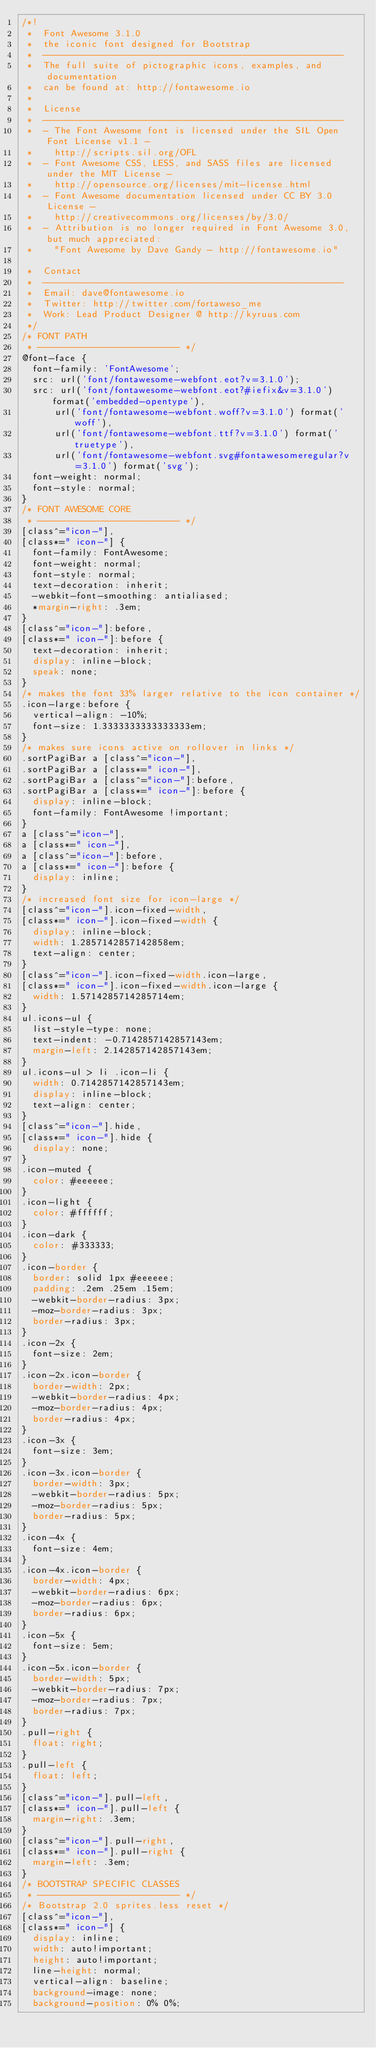<code> <loc_0><loc_0><loc_500><loc_500><_CSS_>/*!
 *  Font Awesome 3.1.0
 *  the iconic font designed for Bootstrap
 *  -------------------------------------------------------
 *  The full suite of pictographic icons, examples, and documentation
 *  can be found at: http://fontawesome.io
 *
 *  License
 *  -------------------------------------------------------
 *  - The Font Awesome font is licensed under the SIL Open Font License v1.1 -
 *    http://scripts.sil.org/OFL
 *  - Font Awesome CSS, LESS, and SASS files are licensed under the MIT License -
 *    http://opensource.org/licenses/mit-license.html
 *  - Font Awesome documentation licensed under CC BY 3.0 License -
 *    http://creativecommons.org/licenses/by/3.0/
 *  - Attribution is no longer required in Font Awesome 3.0, but much appreciated:
 *    "Font Awesome by Dave Gandy - http://fontawesome.io"

 *  Contact
 *  -------------------------------------------------------
 *  Email: dave@fontawesome.io
 *  Twitter: http://twitter.com/fortaweso_me
 *  Work: Lead Product Designer @ http://kyruus.com
 */
/* FONT PATH
 * -------------------------- */
@font-face {
  font-family: 'FontAwesome';
  src: url('font/fontawesome-webfont.eot?v=3.1.0');
  src: url('font/fontawesome-webfont.eot?#iefix&v=3.1.0') format('embedded-opentype'),
      url('font/fontawesome-webfont.woff?v=3.1.0') format('woff'),
      url('font/fontawesome-webfont.ttf?v=3.1.0') format('truetype'),
      url('font/fontawesome-webfont.svg#fontawesomeregular?v=3.1.0') format('svg');
  font-weight: normal;
  font-style: normal;
}
/* FONT AWESOME CORE
 * -------------------------- */
[class^="icon-"],
[class*=" icon-"] {
  font-family: FontAwesome;
  font-weight: normal;
  font-style: normal;
  text-decoration: inherit;
  -webkit-font-smoothing: antialiased;
  *margin-right: .3em;
}
[class^="icon-"]:before,
[class*=" icon-"]:before {
  text-decoration: inherit;
  display: inline-block;
  speak: none;
}
/* makes the font 33% larger relative to the icon container */
.icon-large:before {
  vertical-align: -10%;
  font-size: 1.3333333333333333em;
}
/* makes sure icons active on rollover in links */
.sortPagiBar a [class^="icon-"],
.sortPagiBar a [class*=" icon-"],
.sortPagiBar a [class^="icon-"]:before,
.sortPagiBar a [class*=" icon-"]:before {
  display: inline-block;
  font-family: FontAwesome !important;
}
a [class^="icon-"],
a [class*=" icon-"],
a [class^="icon-"]:before,
a [class*=" icon-"]:before {
  display: inline;
}
/* increased font size for icon-large */
[class^="icon-"].icon-fixed-width,
[class*=" icon-"].icon-fixed-width {
  display: inline-block;
  width: 1.2857142857142858em;
  text-align: center;
}
[class^="icon-"].icon-fixed-width.icon-large,
[class*=" icon-"].icon-fixed-width.icon-large {
  width: 1.5714285714285714em;
}
ul.icons-ul {
  list-style-type: none;
  text-indent: -0.7142857142857143em;
  margin-left: 2.142857142857143em;
}
ul.icons-ul > li .icon-li {
  width: 0.7142857142857143em;
  display: inline-block;
  text-align: center;
}
[class^="icon-"].hide,
[class*=" icon-"].hide {
  display: none;
}
.icon-muted {
  color: #eeeeee;
}
.icon-light {
  color: #ffffff;
}
.icon-dark {
  color: #333333;
}
.icon-border {
  border: solid 1px #eeeeee;
  padding: .2em .25em .15em;
  -webkit-border-radius: 3px;
  -moz-border-radius: 3px;
  border-radius: 3px;
}
.icon-2x {
  font-size: 2em;
}
.icon-2x.icon-border {
  border-width: 2px;
  -webkit-border-radius: 4px;
  -moz-border-radius: 4px;
  border-radius: 4px;
}
.icon-3x {
  font-size: 3em;
}
.icon-3x.icon-border {
  border-width: 3px;
  -webkit-border-radius: 5px;
  -moz-border-radius: 5px;
  border-radius: 5px;
}
.icon-4x {
  font-size: 4em;
}
.icon-4x.icon-border {
  border-width: 4px;
  -webkit-border-radius: 6px;
  -moz-border-radius: 6px;
  border-radius: 6px;
}
.icon-5x {
  font-size: 5em;
}
.icon-5x.icon-border {
  border-width: 5px;
  -webkit-border-radius: 7px;
  -moz-border-radius: 7px;
  border-radius: 7px;
}
.pull-right {
  float: right;
}
.pull-left {
  float: left;
}
[class^="icon-"].pull-left,
[class*=" icon-"].pull-left {
  margin-right: .3em;
}
[class^="icon-"].pull-right,
[class*=" icon-"].pull-right {
  margin-left: .3em;
}
/* BOOTSTRAP SPECIFIC CLASSES
 * -------------------------- */
/* Bootstrap 2.0 sprites.less reset */
[class^="icon-"],
[class*=" icon-"] {
  display: inline;
  width: auto!important;
  height: auto!important;
  line-height: normal;
  vertical-align: baseline;
  background-image: none;
  background-position: 0% 0%;</code> 